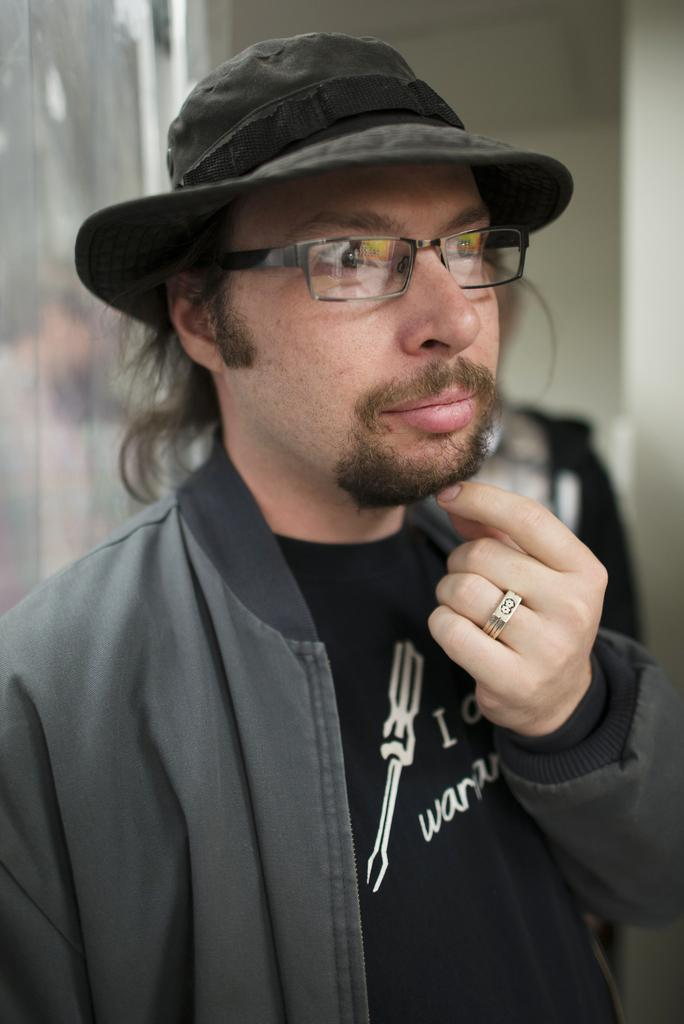Who is the main subject in the image? There is a man in the center of the image. Can you describe the position of the second man in the image? There is another man behind him. What can be seen in the background of the image? There is a portrait in the background of the image. What type of flesh can be seen on the ground in the image? There is no flesh visible on the ground in the image. How much dirt is present in the image? There is no dirt present in the image. 